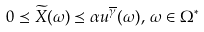<formula> <loc_0><loc_0><loc_500><loc_500>0 \preceq \widetilde { X } ( \omega ) \preceq \alpha u ^ { \overline { \gamma } } ( \omega ) , \, \omega \in \Omega ^ { \ast }</formula> 